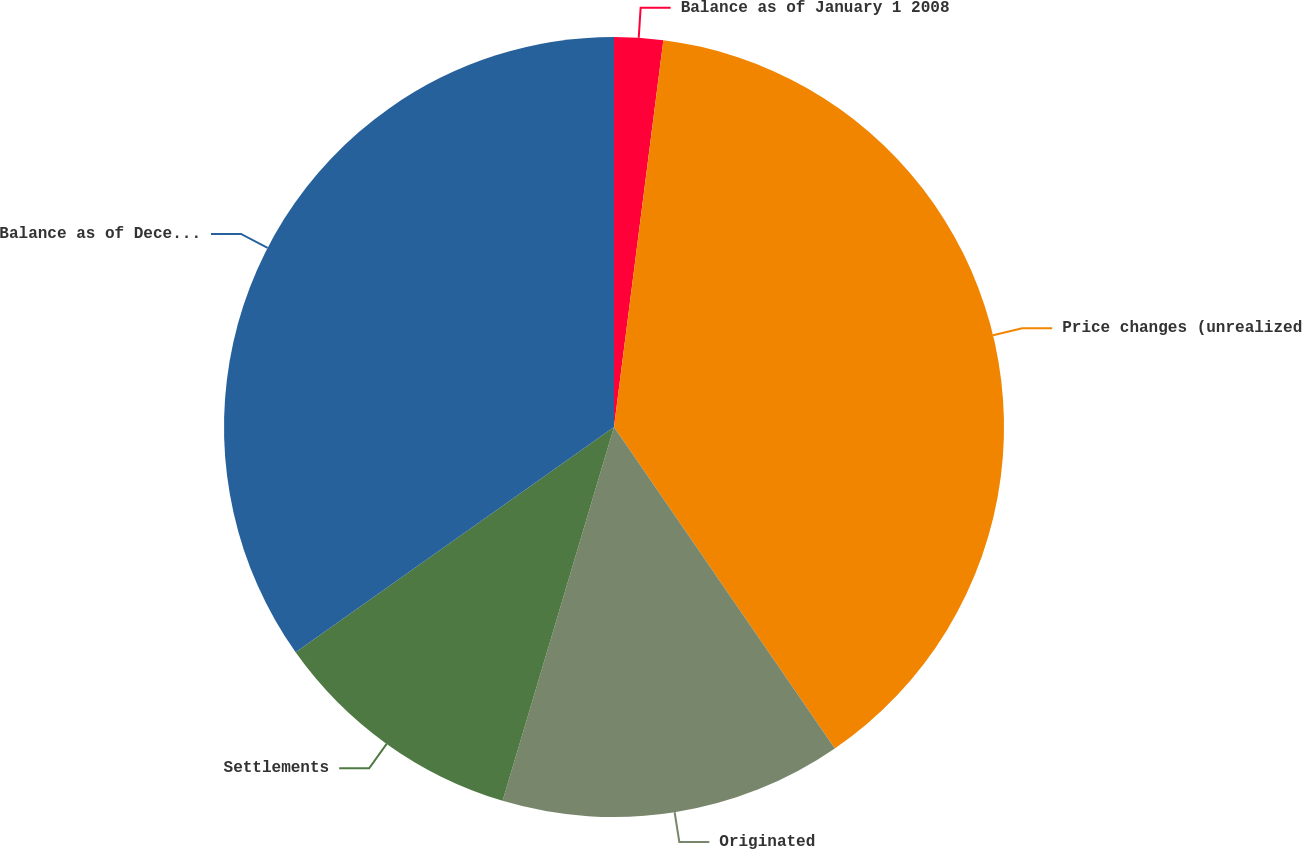<chart> <loc_0><loc_0><loc_500><loc_500><pie_chart><fcel>Balance as of January 1 2008<fcel>Price changes (unrealized<fcel>Originated<fcel>Settlements<fcel>Balance as of December 31 2008<nl><fcel>2.02%<fcel>38.4%<fcel>14.19%<fcel>10.59%<fcel>34.8%<nl></chart> 